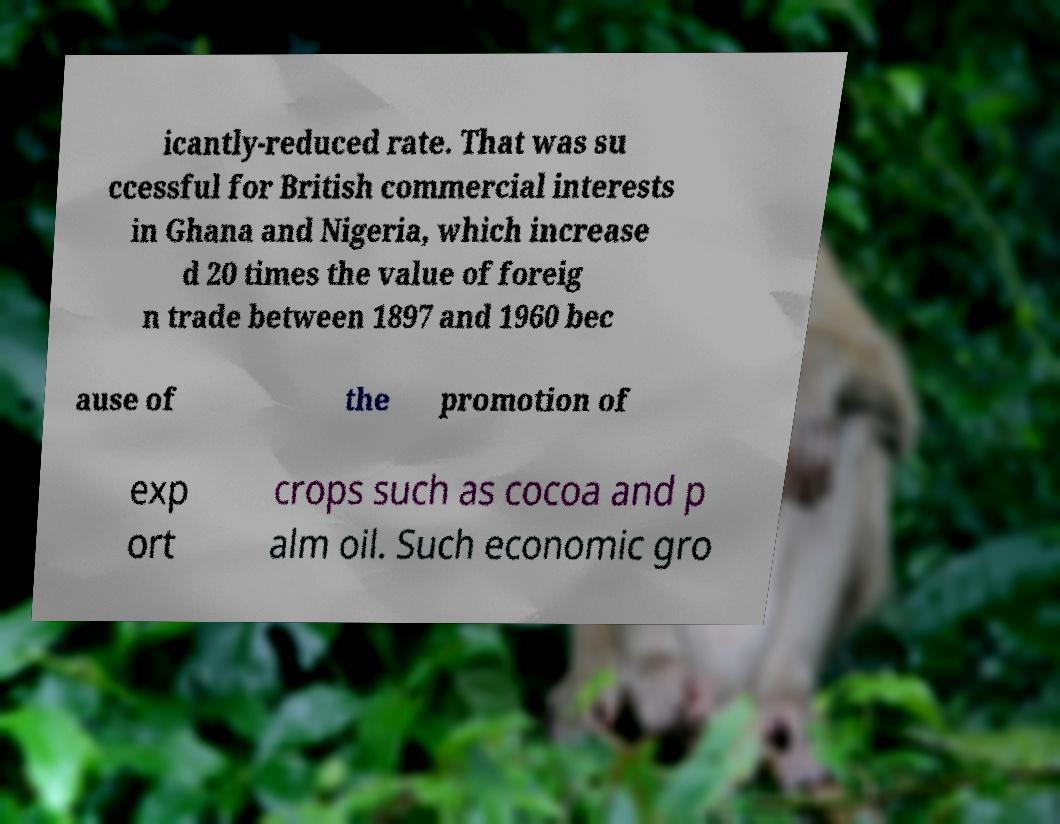Please read and relay the text visible in this image. What does it say? icantly-reduced rate. That was su ccessful for British commercial interests in Ghana and Nigeria, which increase d 20 times the value of foreig n trade between 1897 and 1960 bec ause of the promotion of exp ort crops such as cocoa and p alm oil. Such economic gro 